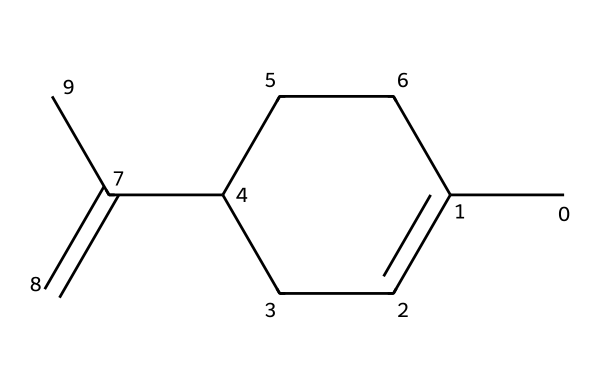What is the systematic name of this compound? The compound's systematic name is derived from its structure. It is a bicyclic monoterpene with the formula C10H16, known for its citrus aroma.
Answer: limonene How many carbon atoms are present in limonene? In the SMILES representation, we can count the number of carbon atoms (C) by identifying the symbols in the structure. There are ten carbon atoms in total.
Answer: 10 What type of molecular structure does limonene exhibit? The structure of limonene is characterized by a ring (bicyclic), which is a feature typical for certain terpenes. This structural form can be inferred from the cyclic arrangement of carbon atoms in the SMILES.
Answer: bicyclic Is limonene a polar or nonpolar compound? To determine polarity, we assess the functional groups and overall molecular structure in the SMILES. With its hydrocarbons and absence of polar functional groups, it is nonpolar.
Answer: nonpolar How many double bonds are present in the structure of limonene? By examining the structure in the SMILES representation, we can identify the presence of double bonds. The two carbon-carbon double bonds are evident in the side chains of the structure.
Answer: 2 Does limonene have any functional groups? The structural formula indicates that limonene is primarily composed of carbon and hydrogen with no identifiable functional groups like -OH or -COOH. Therefore, it does not have any functional groups.
Answer: no What is the role of limonene in food products? Limone's primary role is as a flavoring agent due to its aromatic properties, often used to enhance the taste and scent of food products.
Answer: flavoring agent 